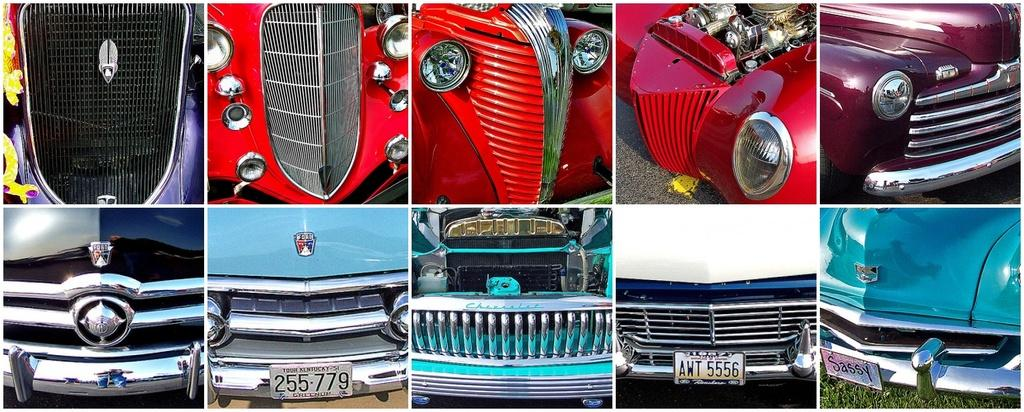What type of image is being described? The image is a collage. What can be seen in the collage? There are front parts of vehicles in the image. What is visible beneath the vehicles? The ground is visible in the image. What type of vegetation is present in the image? There is grass in the image. What type of behavior can be observed in the grass in the image? There is no behavior to observe in the grass in the image, as it is a static representation. 